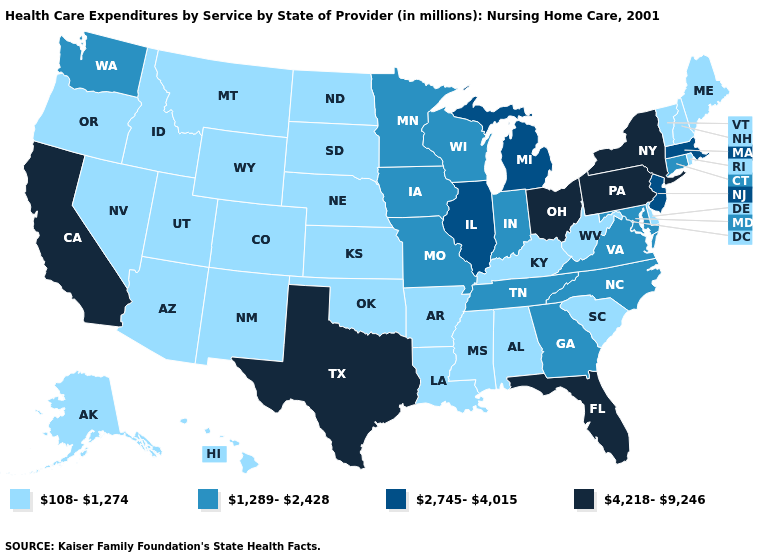Which states have the highest value in the USA?
Short answer required. California, Florida, New York, Ohio, Pennsylvania, Texas. What is the value of New Mexico?
Short answer required. 108-1,274. Among the states that border New York , which have the lowest value?
Answer briefly. Vermont. Which states have the lowest value in the USA?
Keep it brief. Alabama, Alaska, Arizona, Arkansas, Colorado, Delaware, Hawaii, Idaho, Kansas, Kentucky, Louisiana, Maine, Mississippi, Montana, Nebraska, Nevada, New Hampshire, New Mexico, North Dakota, Oklahoma, Oregon, Rhode Island, South Carolina, South Dakota, Utah, Vermont, West Virginia, Wyoming. Name the states that have a value in the range 1,289-2,428?
Keep it brief. Connecticut, Georgia, Indiana, Iowa, Maryland, Minnesota, Missouri, North Carolina, Tennessee, Virginia, Washington, Wisconsin. Name the states that have a value in the range 2,745-4,015?
Write a very short answer. Illinois, Massachusetts, Michigan, New Jersey. Which states have the lowest value in the West?
Write a very short answer. Alaska, Arizona, Colorado, Hawaii, Idaho, Montana, Nevada, New Mexico, Oregon, Utah, Wyoming. What is the highest value in the USA?
Short answer required. 4,218-9,246. Name the states that have a value in the range 1,289-2,428?
Be succinct. Connecticut, Georgia, Indiana, Iowa, Maryland, Minnesota, Missouri, North Carolina, Tennessee, Virginia, Washington, Wisconsin. What is the value of New Mexico?
Short answer required. 108-1,274. Name the states that have a value in the range 108-1,274?
Be succinct. Alabama, Alaska, Arizona, Arkansas, Colorado, Delaware, Hawaii, Idaho, Kansas, Kentucky, Louisiana, Maine, Mississippi, Montana, Nebraska, Nevada, New Hampshire, New Mexico, North Dakota, Oklahoma, Oregon, Rhode Island, South Carolina, South Dakota, Utah, Vermont, West Virginia, Wyoming. Name the states that have a value in the range 4,218-9,246?
Write a very short answer. California, Florida, New York, Ohio, Pennsylvania, Texas. What is the value of Delaware?
Keep it brief. 108-1,274. Does Pennsylvania have the highest value in the USA?
Keep it brief. Yes. What is the lowest value in the MidWest?
Concise answer only. 108-1,274. 